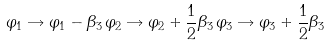<formula> <loc_0><loc_0><loc_500><loc_500>\varphi _ { 1 } \rightarrow \varphi _ { 1 } - \beta _ { 3 } \, \varphi _ { 2 } \rightarrow \varphi _ { 2 } + \frac { 1 } { 2 } \beta _ { 3 } \, \varphi _ { 3 } \rightarrow \varphi _ { 3 } + \frac { 1 } { 2 } \beta _ { 3 }</formula> 